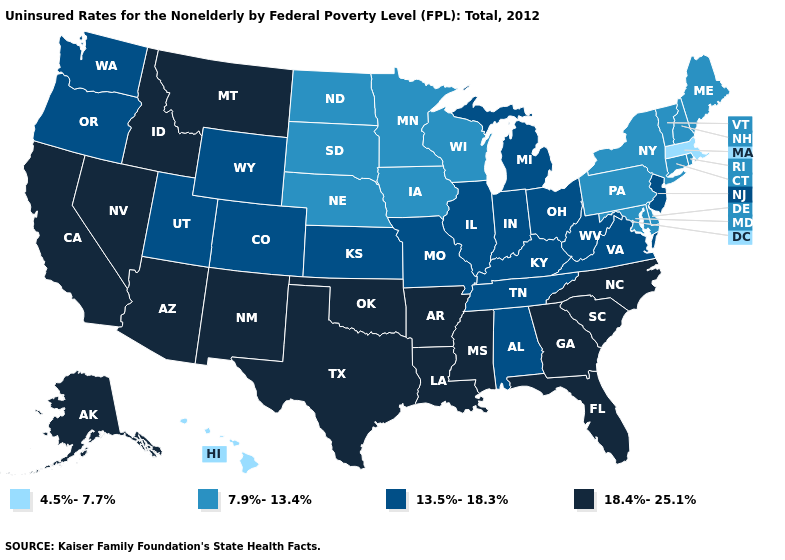Does the map have missing data?
Be succinct. No. Name the states that have a value in the range 18.4%-25.1%?
Concise answer only. Alaska, Arizona, Arkansas, California, Florida, Georgia, Idaho, Louisiana, Mississippi, Montana, Nevada, New Mexico, North Carolina, Oklahoma, South Carolina, Texas. What is the value of Vermont?
Be succinct. 7.9%-13.4%. Among the states that border Idaho , does Nevada have the highest value?
Keep it brief. Yes. Name the states that have a value in the range 13.5%-18.3%?
Answer briefly. Alabama, Colorado, Illinois, Indiana, Kansas, Kentucky, Michigan, Missouri, New Jersey, Ohio, Oregon, Tennessee, Utah, Virginia, Washington, West Virginia, Wyoming. Name the states that have a value in the range 4.5%-7.7%?
Concise answer only. Hawaii, Massachusetts. Does the first symbol in the legend represent the smallest category?
Short answer required. Yes. How many symbols are there in the legend?
Short answer required. 4. What is the value of Michigan?
Short answer required. 13.5%-18.3%. Among the states that border Iowa , does Illinois have the highest value?
Keep it brief. Yes. Name the states that have a value in the range 7.9%-13.4%?
Answer briefly. Connecticut, Delaware, Iowa, Maine, Maryland, Minnesota, Nebraska, New Hampshire, New York, North Dakota, Pennsylvania, Rhode Island, South Dakota, Vermont, Wisconsin. Among the states that border Washington , which have the highest value?
Concise answer only. Idaho. What is the value of Alabama?
Concise answer only. 13.5%-18.3%. What is the highest value in the South ?
Be succinct. 18.4%-25.1%. Among the states that border Delaware , does New Jersey have the lowest value?
Answer briefly. No. 